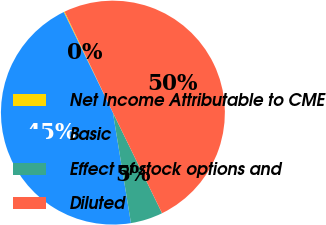Convert chart to OTSL. <chart><loc_0><loc_0><loc_500><loc_500><pie_chart><fcel>Net Income Attributable to CME<fcel>Basic<fcel>Effect of stock options and<fcel>Diluted<nl><fcel>0.13%<fcel>45.34%<fcel>4.66%<fcel>49.87%<nl></chart> 